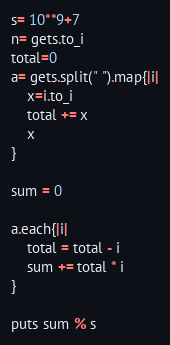<code> <loc_0><loc_0><loc_500><loc_500><_Ruby_>s= 10**9+7
n= gets.to_i
total=0
a= gets.split(" ").map{|i|
    x=i.to_i
    total += x
    x
}

sum = 0

a.each{|i|
    total = total - i
    sum += total * i
}

puts sum % s
</code> 